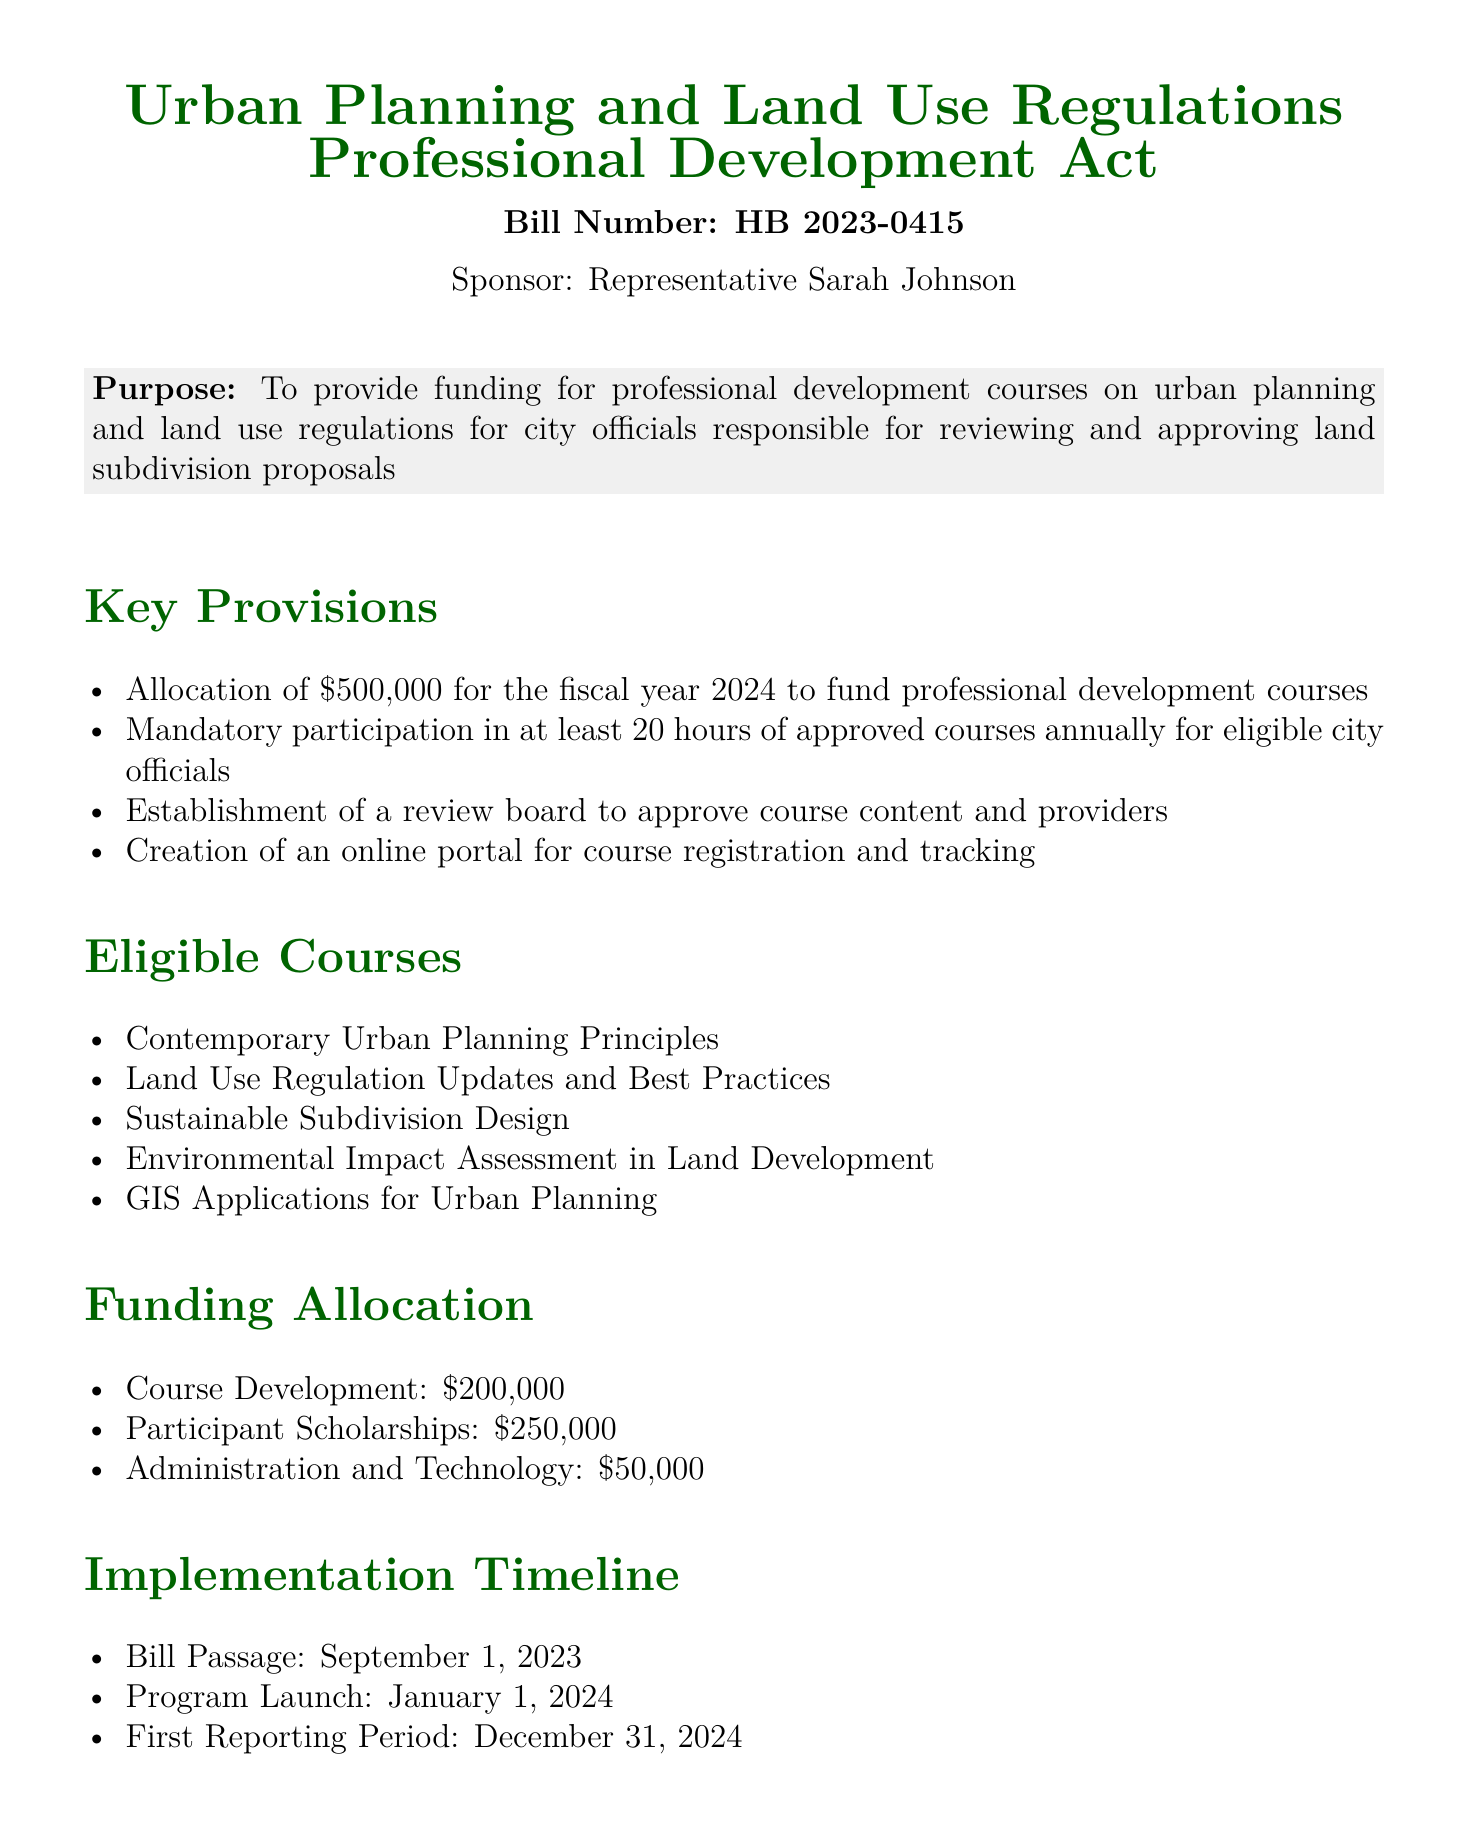What is the bill number? The bill number is explicitly mentioned in the document as HB 2023-0415.
Answer: HB 2023-0415 Who is the sponsor of the bill? The document states that the sponsor of the bill is Representative Sarah Johnson.
Answer: Representative Sarah Johnson What is the total funding allocated for the fiscal year 2024? The document lists the amount allocated as $500,000 for funding professional development courses.
Answer: $500,000 How many hours of approved courses must eligible city officials complete annually? According to the document, eligible city officials are required to participate in at least 20 hours of approved courses annually.
Answer: 20 hours What is the implementation date for the program launch? The document specifies that the program launch is scheduled for January 1, 2024.
Answer: January 1, 2024 What percentage of the funding is allocated for participant scholarships? The funding allocated for participant scholarships is $250,000 out of the total $500,000, which constitutes 50% of the total funding.
Answer: 50% What is one expected outcome of this professional development act? The document lists several expected outcomes, one of which includes enhanced knowledge and skills of city officials.
Answer: Enhanced knowledge and skills How much funding is designated for course development? The document specifies that $200,000 is allocated for course development.
Answer: $200,000 What role does the review board play according to the bill? The review board is established to approve course content and providers as per the document.
Answer: Approve course content and providers 